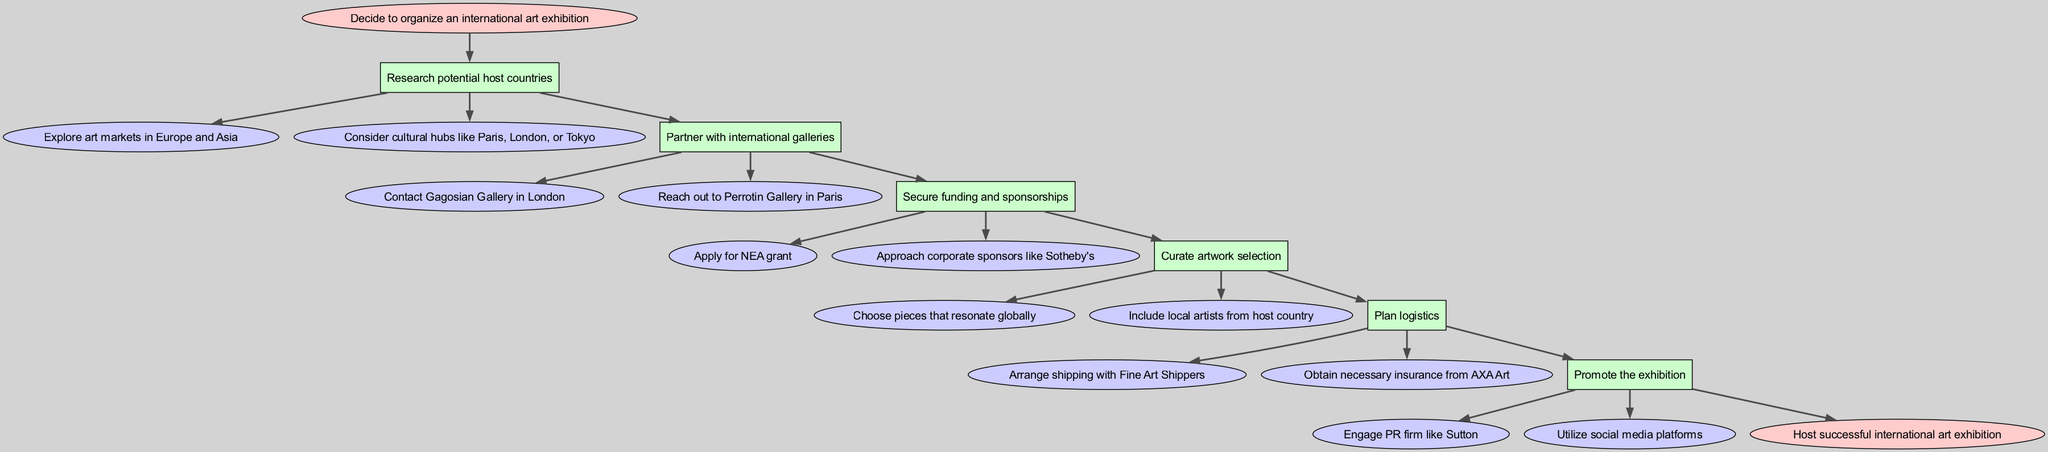What is the first step in organizing the exhibition? The diagram shows that the first step is denoted by the "start" node, which states, "Decide to organize an international art exhibition."
Answer: Decide to organize an international art exhibition How many main steps are there in the process? By counting the nodes representing the main steps in the diagram, we find there are six main steps listed sequentially.
Answer: 6 Which node follows "Partner with international galleries"? The flow of the diagram indicates that the next node after "Partner with international galleries" is "Secure funding and sponsorships."
Answer: Secure funding and sponsorships What is one way to promote the exhibition? The diagram includes "Engage PR firm like Sutton" as one of the substeps under the promotion step.
Answer: Engage PR firm like Sutton What must be done before hosting the exhibition? The final step before hosting is the "Promote the exhibition" step, which indicates that promotion is necessary prior to hosting.
Answer: Promote the exhibition Which substep suggests contacting corporate sponsors? Within the step for securing funding and sponsorships, the substep is "Approach corporate sponsors like Sotheby's," indicating this action is suggested.
Answer: Approach corporate sponsors like Sotheby's What type of artists should be included in the artwork selection? The corresponding substep under "Curate artwork selection" highlights the inclusion of "local artists from host country," indicating that these artists should be a part of the selection.
Answer: Local artists from host country How do the steps connect to lead to the final goal? The diagram shows a linear progression from the start node through various steps and substeps, eventually leading to the "Host successful international art exhibition" node as the final objective.
Answer: Host successful international art exhibition 